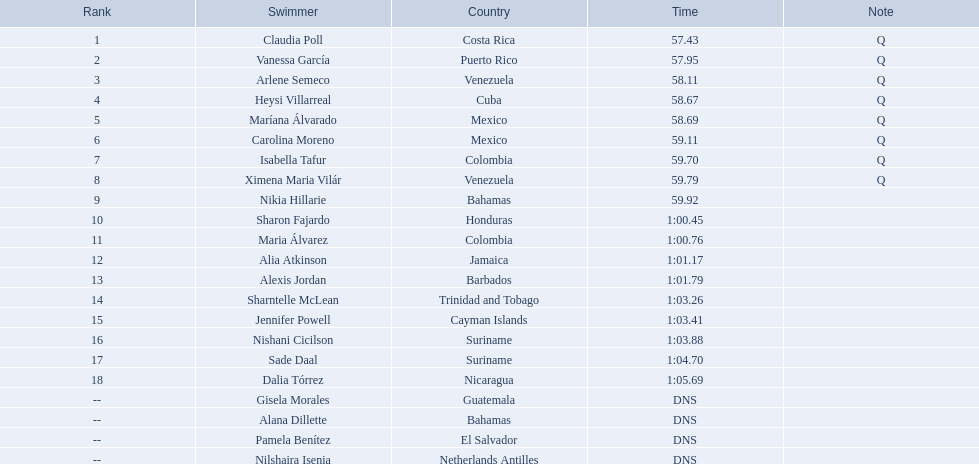From which nations did the top eight participants originate? Costa Rica, Puerto Rico, Venezuela, Cuba, Mexico, Mexico, Colombia, Venezuela. Did any of them represent cuba? Heysi Villarreal. 